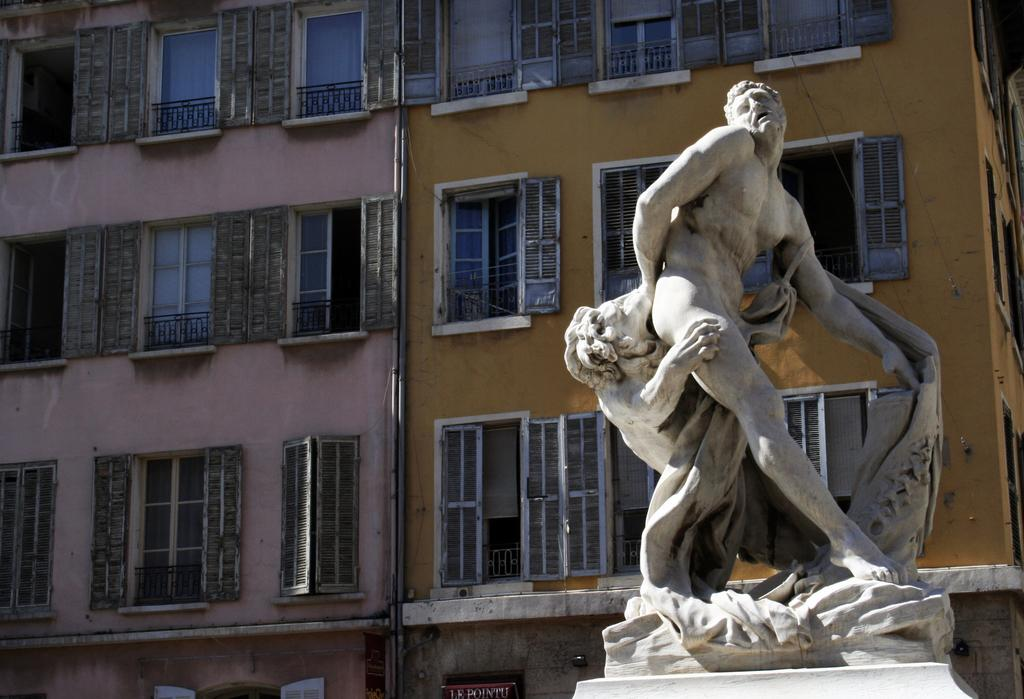What type of structures can be seen in the image? There are buildings in the image. Where are the statues located in the image? The statues are on the right side of the image. What type of canvas is being used by the lettuce in the image? There is no canvas or lettuce present in the image. What part of the statue is being used to support the buildings in the image? The image does not show any interaction between the statues and buildings, so it is not possible to determine if any part of the statue is being used to support the buildings. 